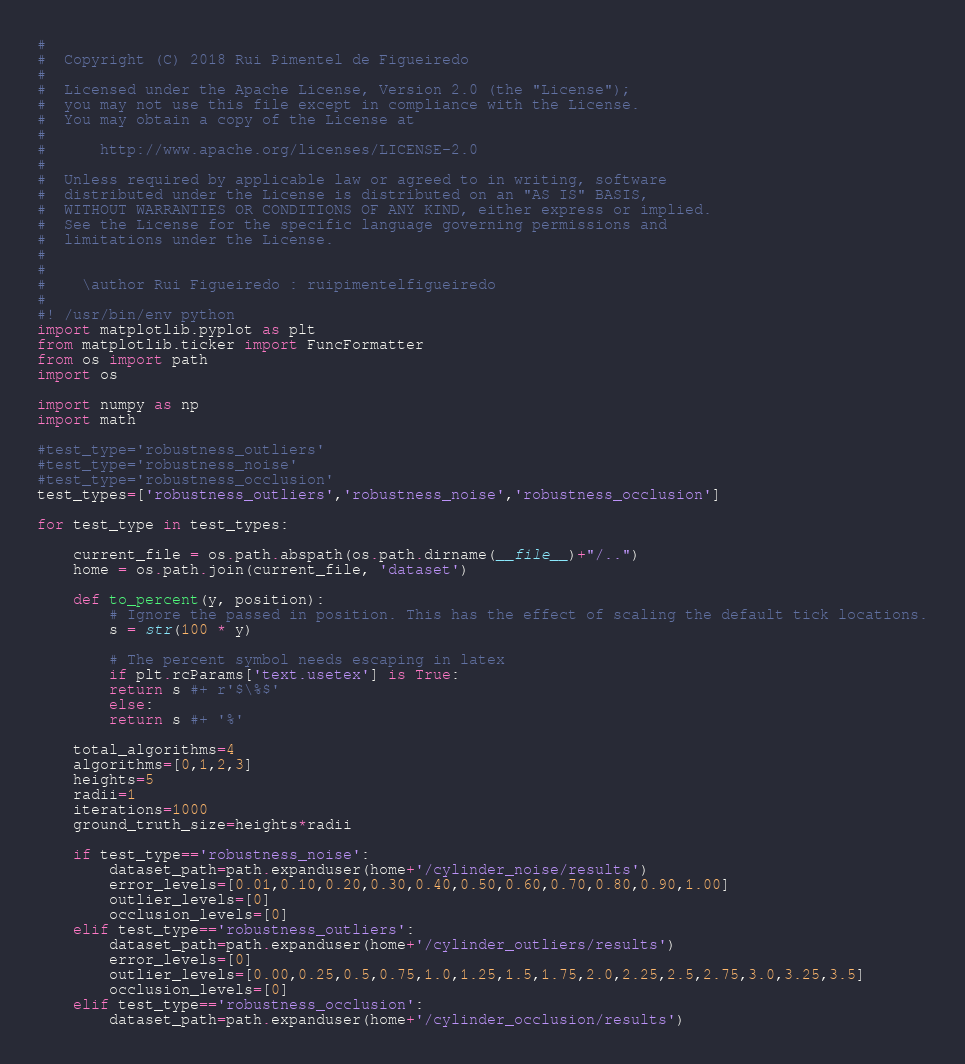Convert code to text. <code><loc_0><loc_0><loc_500><loc_500><_Python_>#
#  Copyright (C) 2018 Rui Pimentel de Figueiredo
#
#  Licensed under the Apache License, Version 2.0 (the "License");
#  you may not use this file except in compliance with the License.
#  You may obtain a copy of the License at
#  
#      http://www.apache.org/licenses/LICENSE-2.0
#      
#  Unless required by applicable law or agreed to in writing, software
#  distributed under the License is distributed on an "AS IS" BASIS,
#  WITHOUT WARRANTIES OR CONDITIONS OF ANY KIND, either express or implied.
#  See the License for the specific language governing permissions and
#  limitations under the License.
#
#    
#    \author Rui Figueiredo : ruipimentelfigueiredo
#
#! /usr/bin/env python
import matplotlib.pyplot as plt
from matplotlib.ticker import FuncFormatter
from os import path
import os 

import numpy as np
import math

#test_type='robustness_outliers'
#test_type='robustness_noise'
#test_type='robustness_occlusion'
test_types=['robustness_outliers','robustness_noise','robustness_occlusion']

for test_type in test_types:

	current_file = os.path.abspath(os.path.dirname(__file__)+"/..")
	home = os.path.join(current_file, 'dataset')

	def to_percent(y, position):
	    # Ignore the passed in position. This has the effect of scaling the default tick locations.
	    s = str(100 * y)

	    # The percent symbol needs escaping in latex
	    if plt.rcParams['text.usetex'] is True:
		return s #+ r'$\%$'
	    else:
		return s #+ '%'

	total_algorithms=4
	algorithms=[0,1,2,3]
	heights=5
	radii=1
	iterations=1000
	ground_truth_size=heights*radii

	if test_type=='robustness_noise':
	    dataset_path=path.expanduser(home+'/cylinder_noise/results')
	    error_levels=[0.01,0.10,0.20,0.30,0.40,0.50,0.60,0.70,0.80,0.90,1.00]
	    outlier_levels=[0]
	    occlusion_levels=[0]
	elif test_type=='robustness_outliers':
	    dataset_path=path.expanduser(home+'/cylinder_outliers/results')
	    error_levels=[0]
	    outlier_levels=[0.00,0.25,0.5,0.75,1.0,1.25,1.5,1.75,2.0,2.25,2.5,2.75,3.0,3.25,3.5]
	    occlusion_levels=[0]
	elif test_type=='robustness_occlusion':
	    dataset_path=path.expanduser(home+'/cylinder_occlusion/results')</code> 